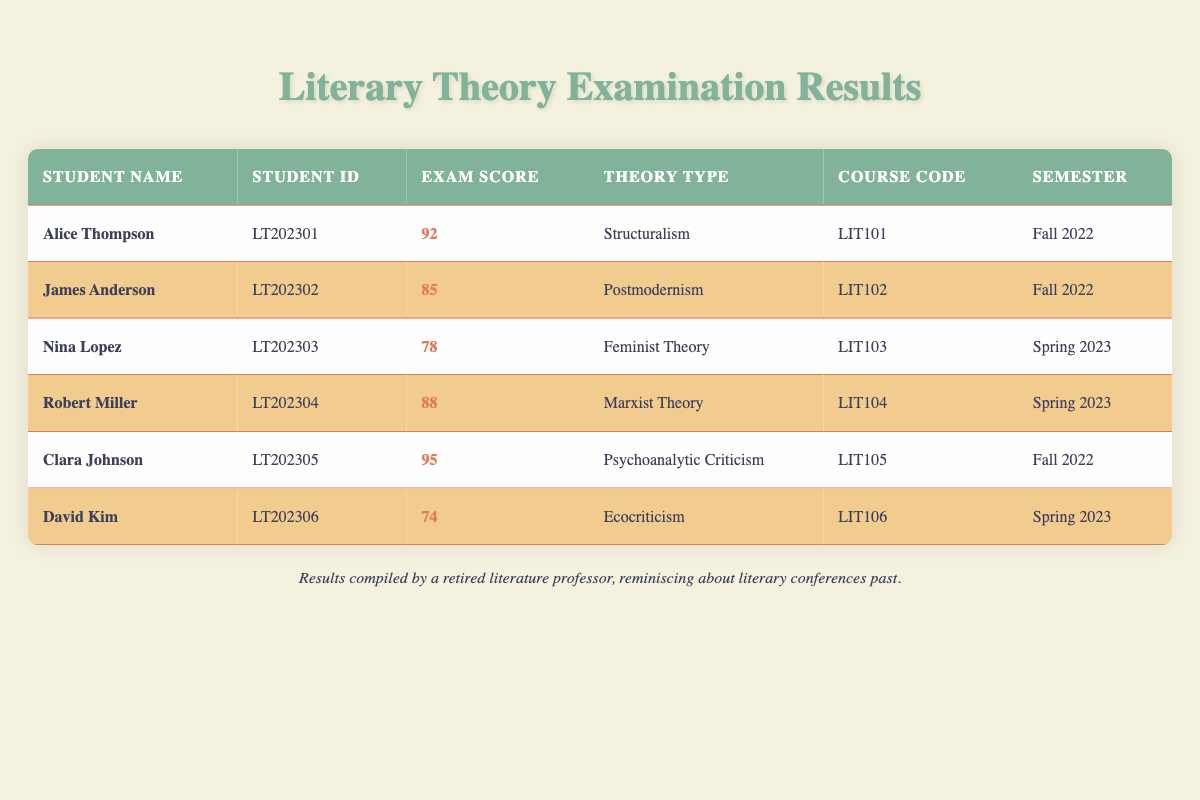What is the highest exam score in the table? The highest score in the table is found in the exam scores column. Upon reviewing, Clara Johnson has scored 95, which is the highest among all students listed.
Answer: 95 Who scored below 80 in their examination? By reviewing the exam scores in the table, I see that Nina Lopez (78) and David Kim (74) scored below 80. Thus, they are the only students with scores in that range.
Answer: Nina Lopez, David Kim What is the average exam score for the Spring 2023 semester? The relevant scores for Spring 2023 are 78 (Nina Lopez) and 74 (David Kim), summing them gives 78 + 74 = 152. There are two students, so the average score is 152 divided by 2, resulting in 76.
Answer: 76 Did any student score 90 or higher on their exam? Scanning through the exam scores, I can see that Alice Thompson (92) and Clara Johnson (95) both scored 90 or above, confirming that at least two students achieved that mark.
Answer: Yes Which theory type had the highest score and what was that score? First, I identify the highest score in the table (which is 95 from Clara Johnson), and I find that this score corresponds to Psychoanalytic Criticism. Therefore, that is the highest theory type score recorded.
Answer: Psychoanalytic Criticism, 95 What is the median exam score of all students? To find the median, I need to first list all the exam scores in order: 74, 78, 85, 88, 92, 95. With an even number of entries (6), the median will be the average of the two middle scores, which are 85 and 88. Thus, (85 + 88) / 2 = 166 / 2 = 83.
Answer: 83 Which student achieved the lowest exam score and what theory did they study? A review of the table reveals that David Kim, with a score of 74, has the lowest exam score. The theory type he studied is Ecocriticism.
Answer: David Kim, Ecocriticism How many students took courses related to Feminist Theory and Ecocriticism? According to the table, Nina Lopez is the only student related to Feminist Theory, and David Kim is the only one for Ecocriticism. Therefore, there are two students in total studying these theories.
Answer: 2 